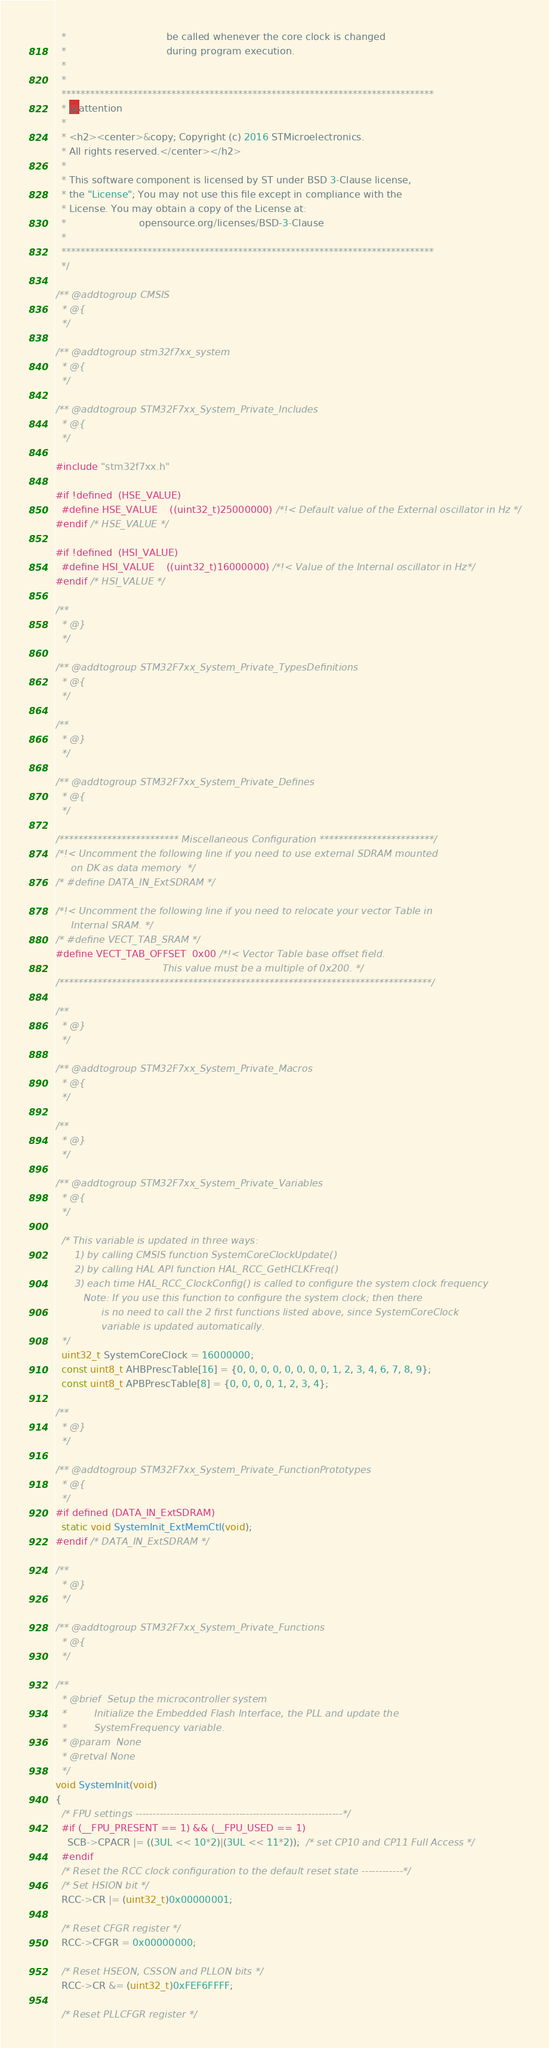<code> <loc_0><loc_0><loc_500><loc_500><_C_>  *                                 be called whenever the core clock is changed
  *                                 during program execution.
  *
  *
  ******************************************************************************
  * @attention
  *
  * <h2><center>&copy; Copyright (c) 2016 STMicroelectronics.
  * All rights reserved.</center></h2>
  *
  * This software component is licensed by ST under BSD 3-Clause license,
  * the "License"; You may not use this file except in compliance with the
  * License. You may obtain a copy of the License at:
  *                        opensource.org/licenses/BSD-3-Clause
  *
  ******************************************************************************
  */

/** @addtogroup CMSIS
  * @{
  */

/** @addtogroup stm32f7xx_system
  * @{
  */  
  
/** @addtogroup STM32F7xx_System_Private_Includes
  * @{
  */

#include "stm32f7xx.h"

#if !defined  (HSE_VALUE) 
  #define HSE_VALUE    ((uint32_t)25000000) /*!< Default value of the External oscillator in Hz */
#endif /* HSE_VALUE */

#if !defined  (HSI_VALUE)
  #define HSI_VALUE    ((uint32_t)16000000) /*!< Value of the Internal oscillator in Hz*/
#endif /* HSI_VALUE */

/**
  * @}
  */

/** @addtogroup STM32F7xx_System_Private_TypesDefinitions
  * @{
  */

/**
  * @}
  */

/** @addtogroup STM32F7xx_System_Private_Defines
  * @{
  */

/************************* Miscellaneous Configuration ************************/
/*!< Uncomment the following line if you need to use external SDRAM mounted
     on DK as data memory  */
/* #define DATA_IN_ExtSDRAM */

/*!< Uncomment the following line if you need to relocate your vector Table in
     Internal SRAM. */
/* #define VECT_TAB_SRAM */
#define VECT_TAB_OFFSET  0x00 /*!< Vector Table base offset field. 
                                   This value must be a multiple of 0x200. */
/******************************************************************************/

/**
  * @}
  */

/** @addtogroup STM32F7xx_System_Private_Macros
  * @{
  */

/**
  * @}
  */

/** @addtogroup STM32F7xx_System_Private_Variables
  * @{
  */

  /* This variable is updated in three ways:
      1) by calling CMSIS function SystemCoreClockUpdate()
      2) by calling HAL API function HAL_RCC_GetHCLKFreq()
      3) each time HAL_RCC_ClockConfig() is called to configure the system clock frequency 
         Note: If you use this function to configure the system clock; then there
               is no need to call the 2 first functions listed above, since SystemCoreClock
               variable is updated automatically.
  */
  uint32_t SystemCoreClock = 16000000;
  const uint8_t AHBPrescTable[16] = {0, 0, 0, 0, 0, 0, 0, 0, 1, 2, 3, 4, 6, 7, 8, 9};
  const uint8_t APBPrescTable[8] = {0, 0, 0, 0, 1, 2, 3, 4};

/**
  * @}
  */

/** @addtogroup STM32F7xx_System_Private_FunctionPrototypes
  * @{
  */
#if defined (DATA_IN_ExtSDRAM)
  static void SystemInit_ExtMemCtl(void); 
#endif /* DATA_IN_ExtSDRAM */

/**
  * @}
  */

/** @addtogroup STM32F7xx_System_Private_Functions
  * @{
  */

/**
  * @brief  Setup the microcontroller system
  *         Initialize the Embedded Flash Interface, the PLL and update the 
  *         SystemFrequency variable.
  * @param  None
  * @retval None
  */
void SystemInit(void)
{
  /* FPU settings ------------------------------------------------------------*/
  #if (__FPU_PRESENT == 1) && (__FPU_USED == 1)
    SCB->CPACR |= ((3UL << 10*2)|(3UL << 11*2));  /* set CP10 and CP11 Full Access */
  #endif
  /* Reset the RCC clock configuration to the default reset state ------------*/
  /* Set HSION bit */
  RCC->CR |= (uint32_t)0x00000001;

  /* Reset CFGR register */
  RCC->CFGR = 0x00000000;

  /* Reset HSEON, CSSON and PLLON bits */
  RCC->CR &= (uint32_t)0xFEF6FFFF;

  /* Reset PLLCFGR register */</code> 